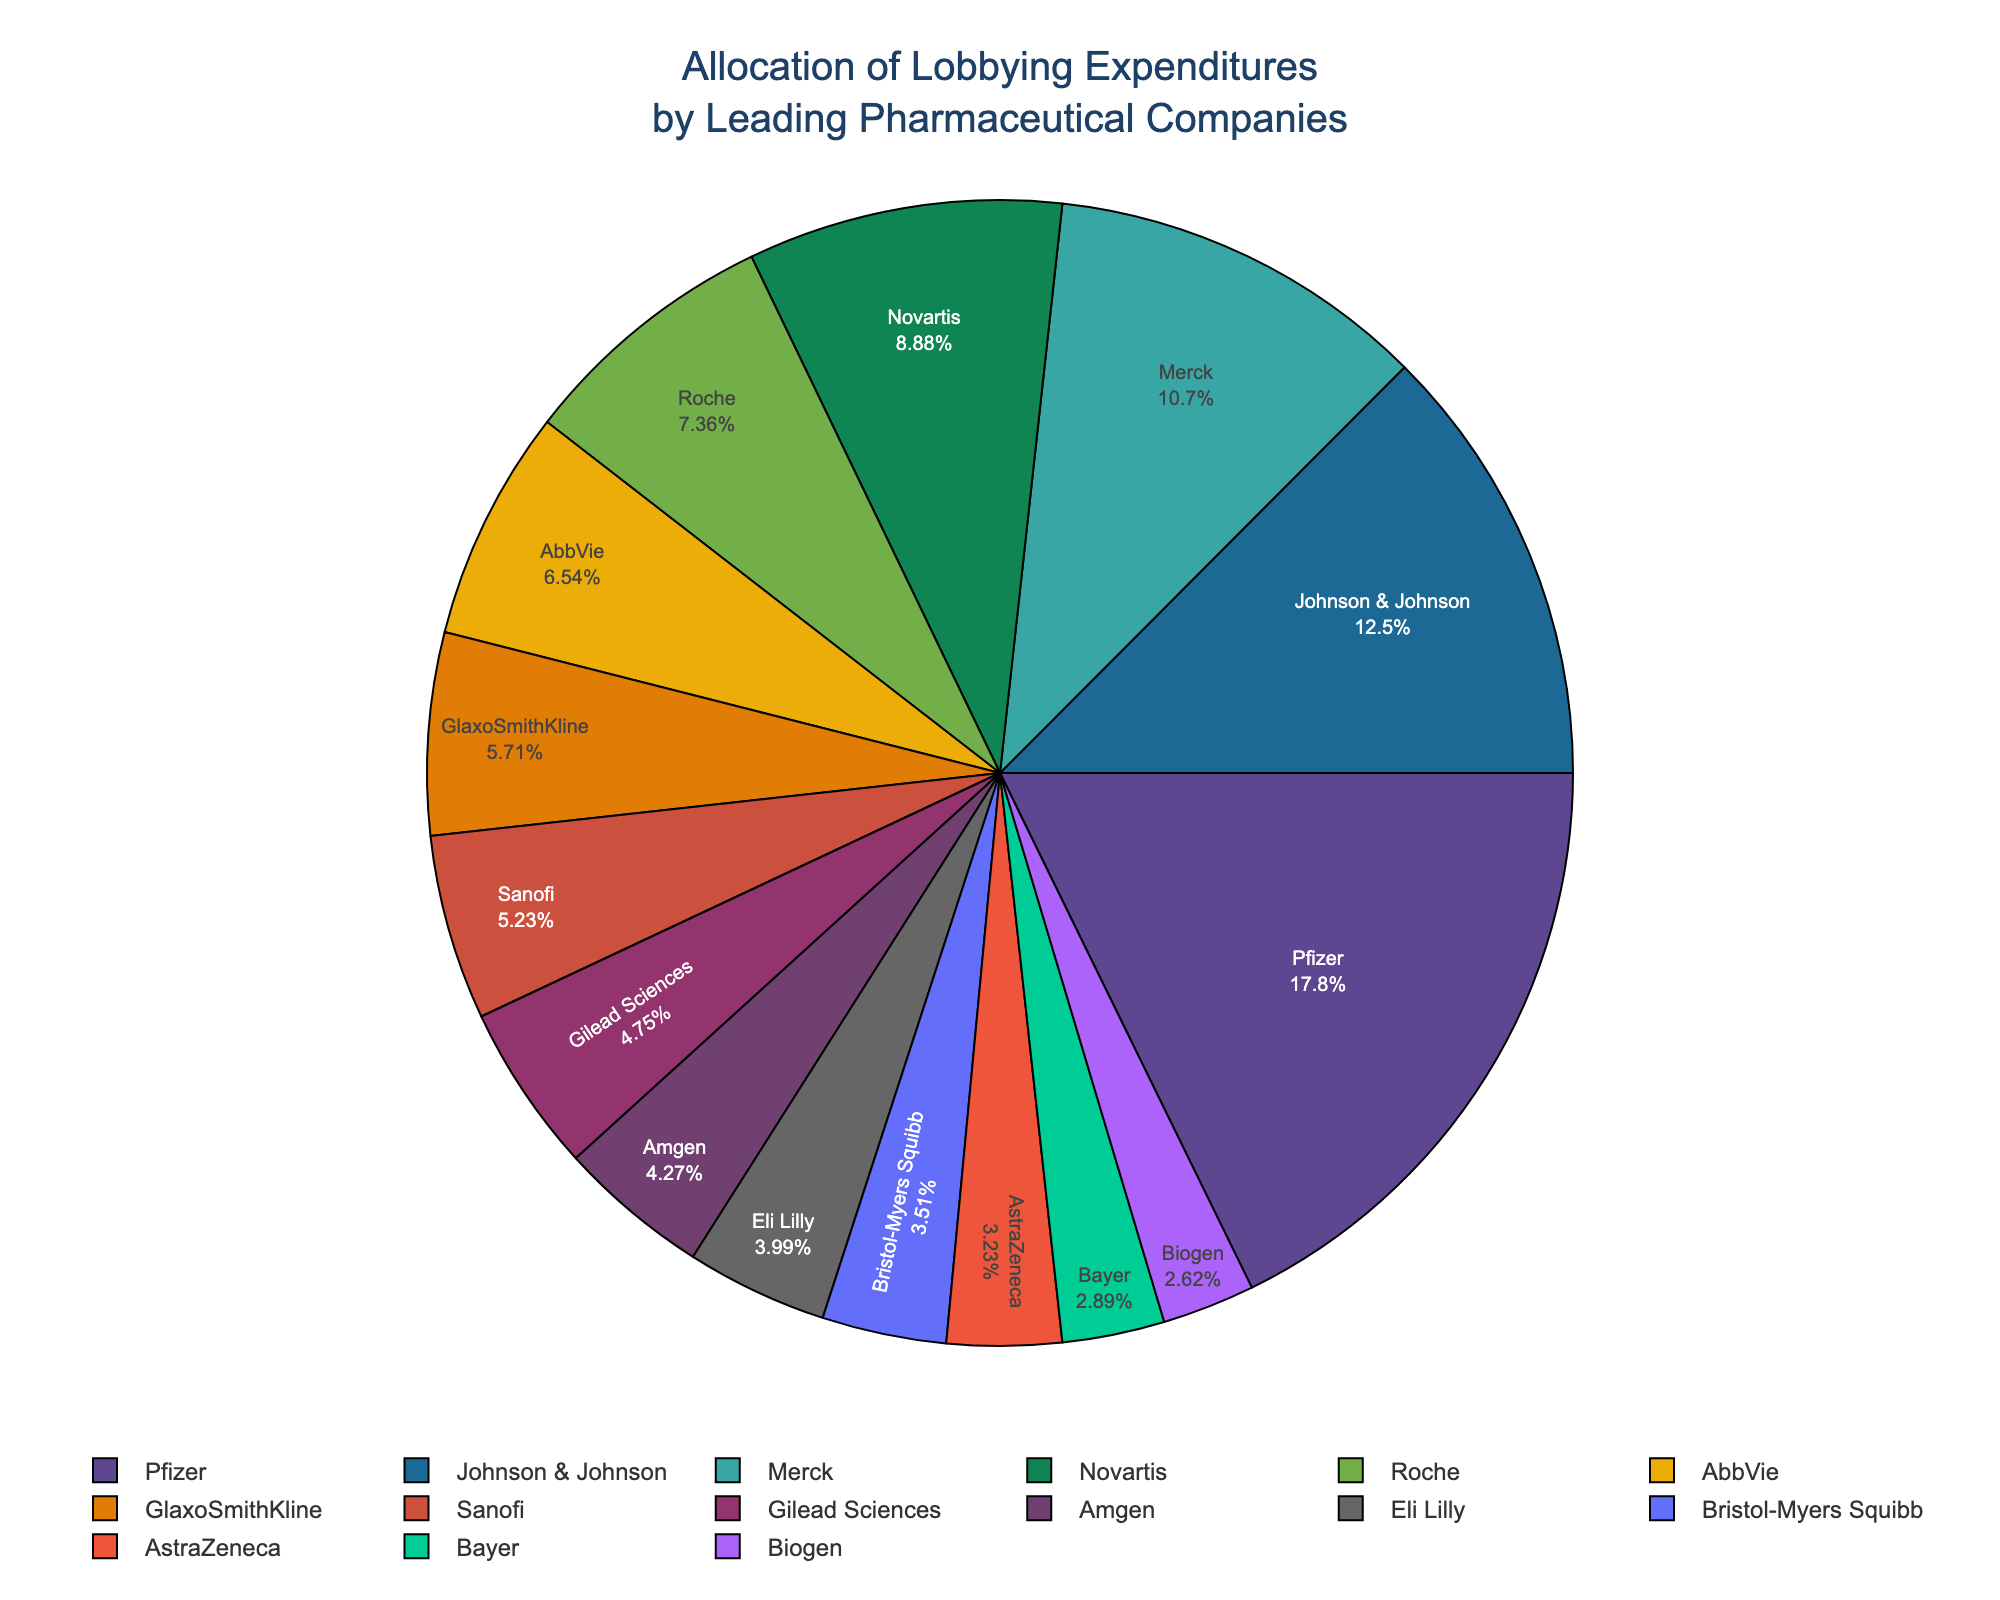What percentage of the total lobbying expenditure is attributed to Pfizer? According to the pie chart, Pfizer’s segment shows the percentage. Locate Pfizer’s label and read off the percentage next to it.
Answer: 18.5% Which two companies have the highest lobbying expenditures and what are their combined expenditures? Identify the two largest segments in the pie chart and read the company names and their values. Pfizer and Johnson & Johnson have the highest expenditures. Their combined expenditure is 25.8 + 18.2 = 44.0 million USD.
Answer: Pfizer and Johnson & Johnson, 44.0 million USD How much more does Pfizer spend on lobbying compared to GlaxoSmithKline? Find the lobbying expenditures for Pfizer and GlaxoSmithKline from the pie chart. The difference is 25.8 - 8.3 = 17.5 million USD.
Answer: 17.5 million USD Which company has the smallest share of the lobbying expenditure and what is its value? Look for the smallest segment in the pie chart and identify the company and its expenditure. Biogen has the smallest share with 3.8 million USD.
Answer: Biogen, 3.8 million USD If you combined the lobbying expenditures of Merck, Novartis, and Roche, what percentage of the total would they represent? Sum the expenditures of Merck (15.6), Novartis (12.9), and Roche (10.7) to get 39.2 million USD. Then calculate the percentage of the total by dividing by the total lobbying expenditure and multiplying by 100. (15.6 + 12.9 + 10.7) / (sum of all expenditures) * 100
Answer: Approximately 28.1% Does Sanofi spend more on lobbying than Eli Lilly? Compare the segments for Sanofi and Eli Lilly. Sanofi spends 7.6 million USD, whereas Eli Lilly spends 5.8 million USD, so Sanofi spends more.
Answer: Yes What is the difference in lobbying expenditures between Amgen and Gilead Sciences? Locate Amgen’s and Gilead Sciences’ expenditures in the pie chart. The difference is 6.9 - 6.2 = 0.7 million USD.
Answer: 0.7 million USD Which company spends closest to 10 million USD on lobbying, and what is the exact amount? Identify the segment that labels the value closest to 10 million USD. Roche spends 10.7 million USD.
Answer: Roche, 10.7 million USD 